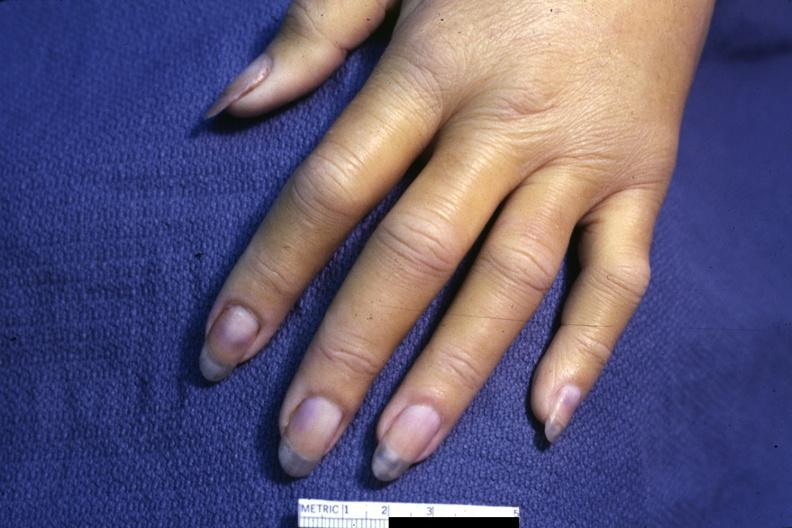how does case of dic not bad photo require dark room to see distal phalangeal cyanosis?
Answer the question using a single word or phrase. Subtle 